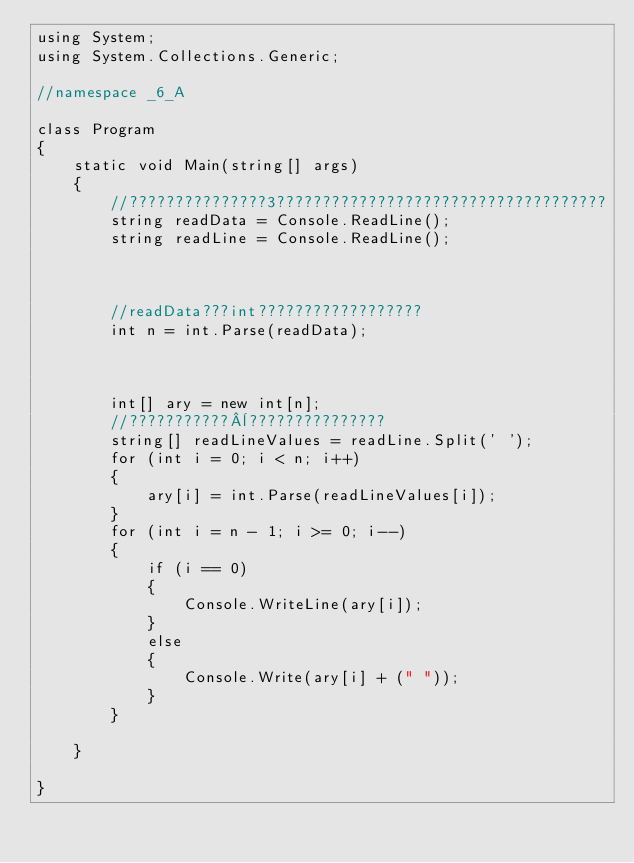Convert code to text. <code><loc_0><loc_0><loc_500><loc_500><_C#_>using System;
using System.Collections.Generic;

//namespace _6_A

class Program
{
    static void Main(string[] args)
    {
        //???????????????3????????????????????????????????????
        string readData = Console.ReadLine();
        string readLine = Console.ReadLine();



        //readData???int??????????????????
        int n = int.Parse(readData);



        int[] ary = new int[n];
        //???????????¨???????????????
        string[] readLineValues = readLine.Split(' ');
        for (int i = 0; i < n; i++)
        {
            ary[i] = int.Parse(readLineValues[i]);
        }
        for (int i = n - 1; i >= 0; i--)
        {
            if (i == 0)
            {
                Console.WriteLine(ary[i]);
            }
            else
            {
                Console.Write(ary[i] + (" "));
            }
        }
        
    }
    
}</code> 